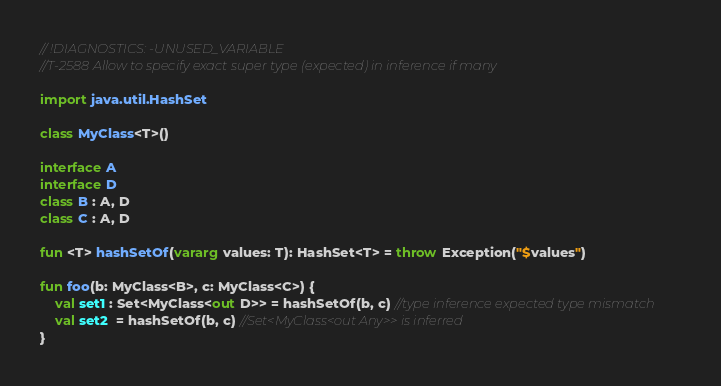Convert code to text. <code><loc_0><loc_0><loc_500><loc_500><_Kotlin_>// !DIAGNOSTICS: -UNUSED_VARIABLE
//T-2588 Allow to specify exact super type (expected) in inference if many

import java.util.HashSet

class MyClass<T>()

interface A
interface D
class B : A, D
class C : A, D

fun <T> hashSetOf(vararg values: T): HashSet<T> = throw Exception("$values")

fun foo(b: MyClass<B>, c: MyClass<C>) {
    val set1 : Set<MyClass<out D>> = hashSetOf(b, c) //type inference expected type mismatch
    val set2  = hashSetOf(b, c) //Set<MyClass<out Any>> is inferred
}</code> 